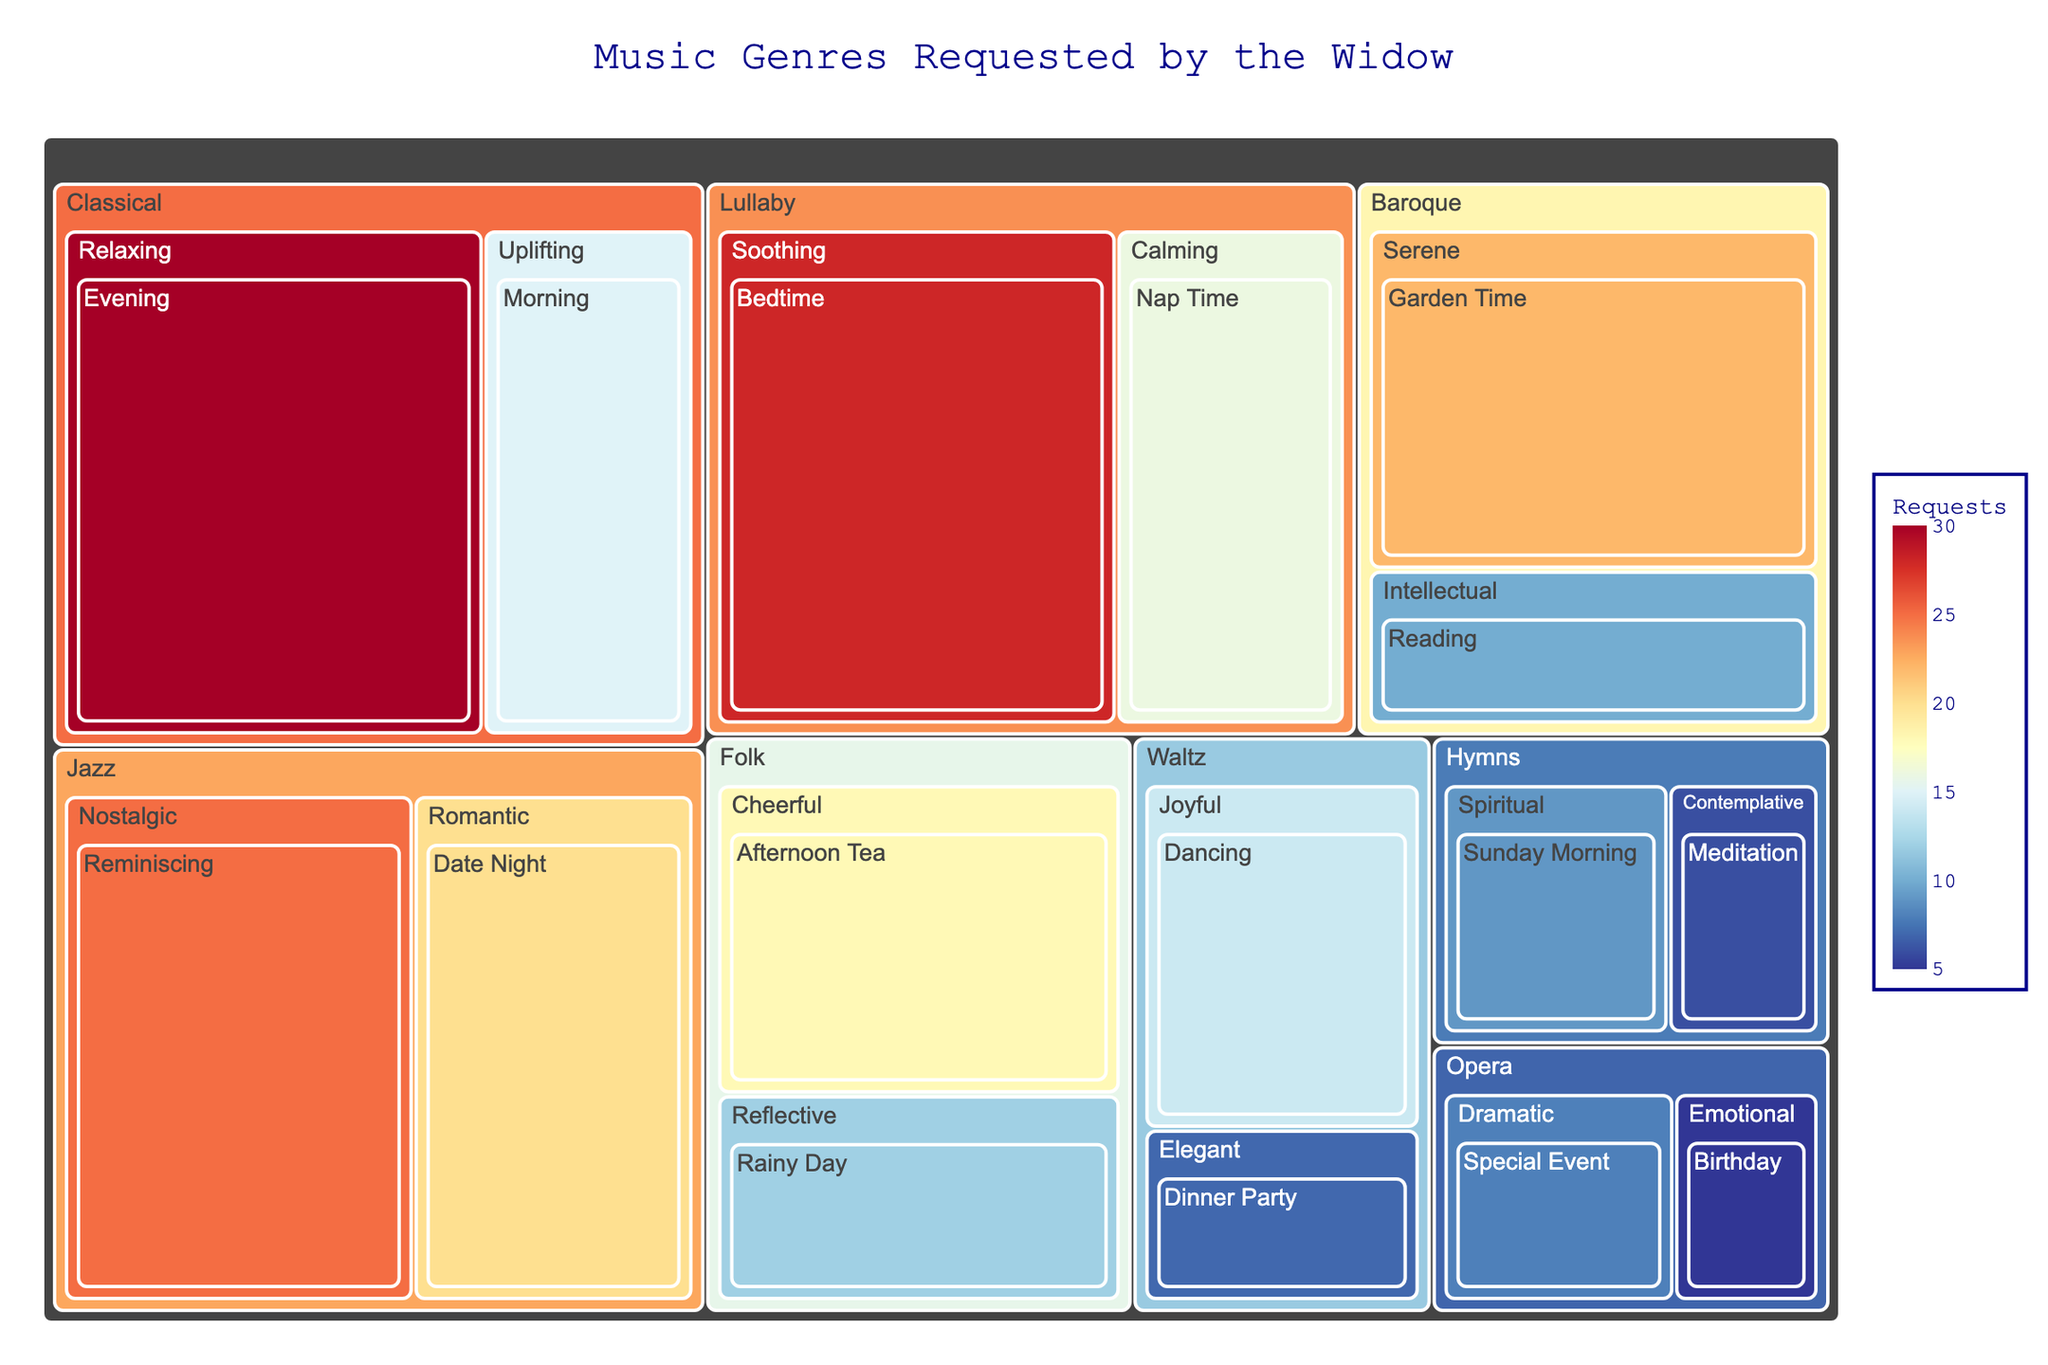What is the title of the treemap? The title is found at the top of the treemap.
Answer: Music Genres Requested by the Widow Which genre has the highest number of requests? The treemap shows genres as the first level of the path, and the size of the rectangles represents the number of requests.
Answer: Classical What is the total number of requests for Jazz across all occasions? The requests for Jazz need to be summed. Jazz has 20 requests for "Romantic Date Night" and 25 requests for "Nostalgic Reminiscing". Summing these values: 20 + 25 = 45.
Answer: 45 Which mood under Folk has more requests: Cheerful or Reflective? Folk has two moods: Cheerful with 18 requests and Reflective with 12 requests. Comparing 18 and 12, Cheerful has more requests.
Answer: Cheerful How many more requests does Lullaby have for Bedtime compared to Nap Time? Lullaby has 28 requests for Bedtime and 16 for Nap Time. The difference can be found by subtracting: 28 - 16 = 12.
Answer: 12 What genre has the least number of requests and what is that number? The smallest rectangle represents the least requests. Opera under the mood "Emotional" for "Birthday" has 5 requests.
Answer: Opera, 5 How many total requests were made for Classical music? Classical has 30 requests for "Relaxing Evening" and 15 requests for "Uplifting Morning". Summing these: 30 + 15 = 45.
Answer: 45 If you add the requests for Baroque and Waltz, what is the total? Baroque has 22 for "Serene Garden Time" and 10 for "Intellectual Reading" (22 + 10 = 32). Waltz has 14 for "Joyful Dancing" and 7 for "Elegant Dinner Party" (14 + 7 = 21). Summing all these: 32 + 21 = 53.
Answer: 53 Which genre-mood combination has exactly 10 requests? From the treemap, Baroque under the mood "Intellectual" for the occasion "Reading" has exactly 10 requests.
Answer: Baroque-Intellectual Is there any genre with equal requests for two different occasions? Yes, Lullaby has 28 requests for "Bedtime" and 28 requests for "Nap Time"
Answer: No 